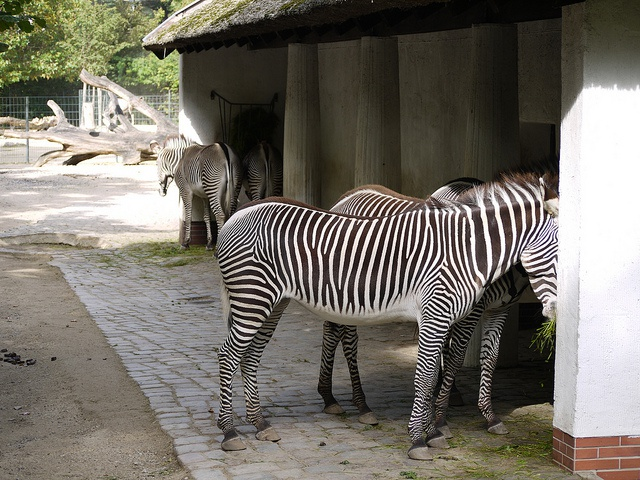Describe the objects in this image and their specific colors. I can see zebra in darkgreen, black, lightgray, gray, and darkgray tones, zebra in darkgreen, black, and gray tones, zebra in darkgreen, gray, black, darkgray, and lightgray tones, and zebra in darkgreen, black, and gray tones in this image. 